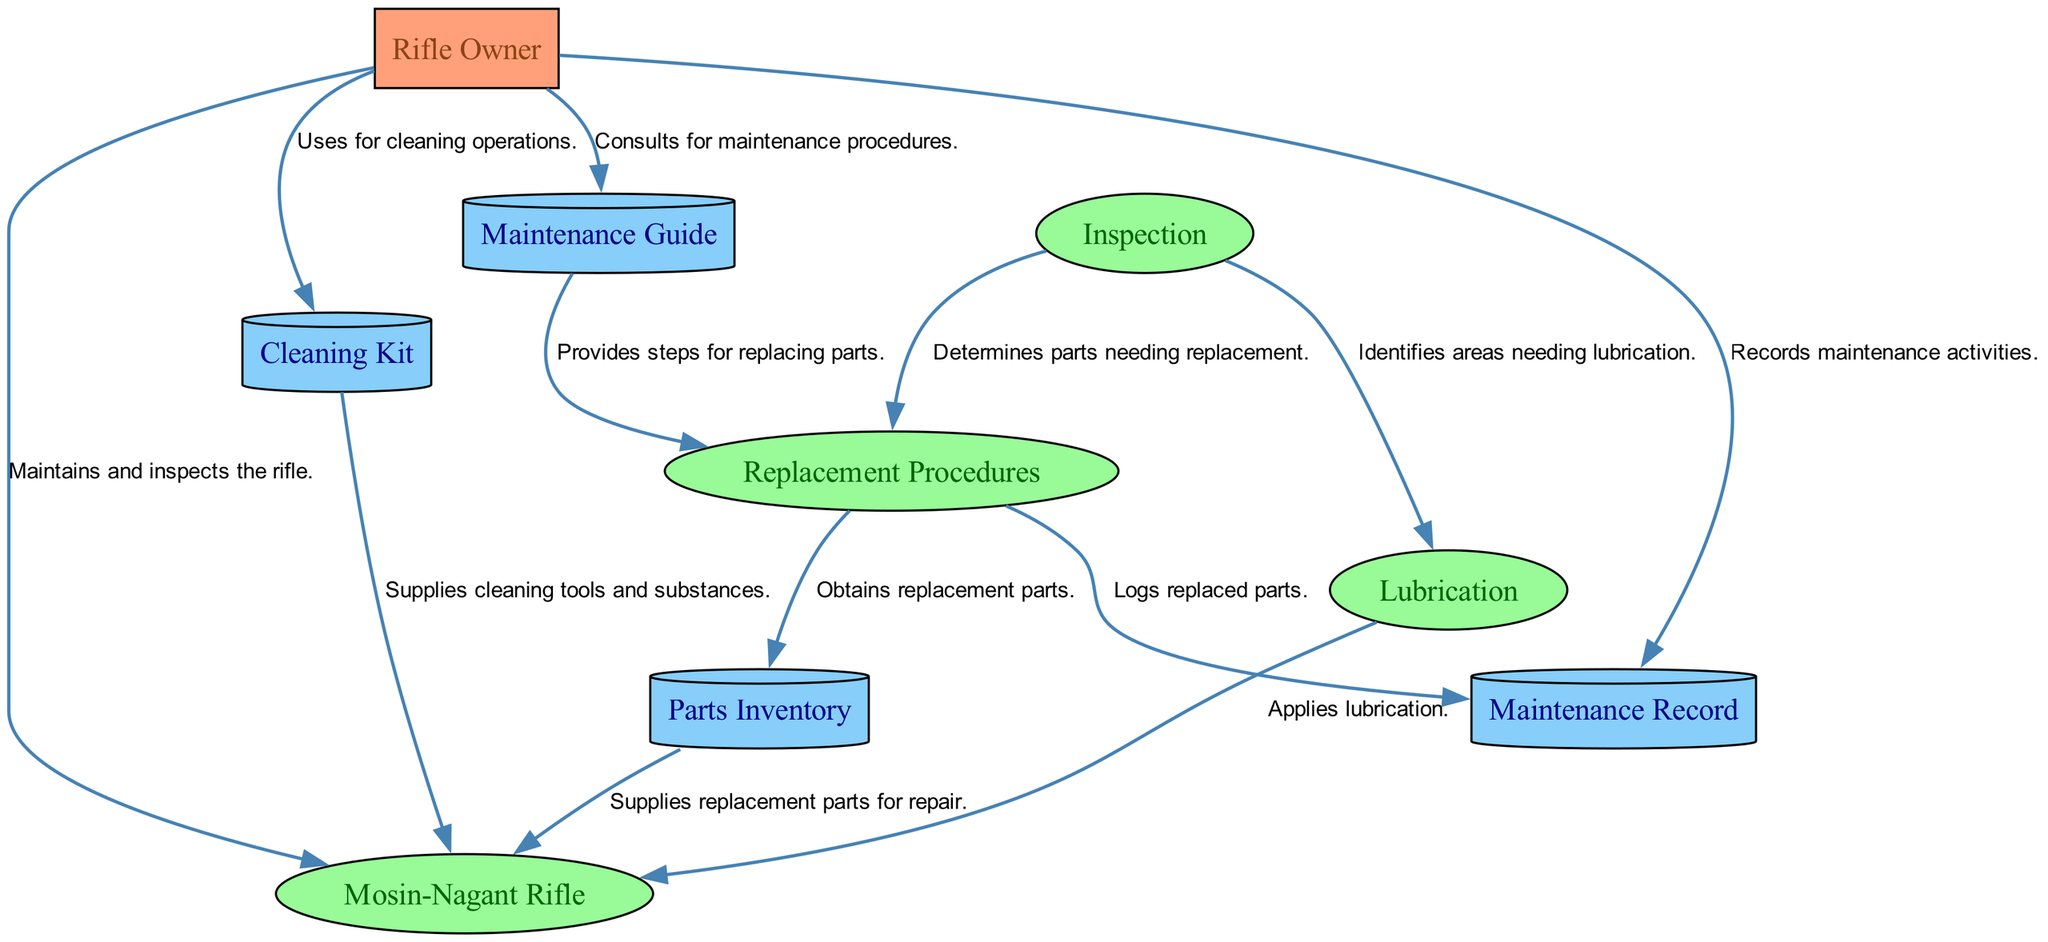What is the main process being maintained in this diagram? The diagram focuses on the Mosin-Nagant Rifle, which is identified as the main process in the entity list.
Answer: Mosin-Nagant Rifle How many external entities are present in the diagram? There is one external entity, which is the Rifle Owner responsible for maintenance and inspections.
Answer: One What is the purpose of the Maintenance Guide? It provides documentation detailing the steps for maintaining and replacing parts on the Mosin-Nagant rifle.
Answer: Documentation Which process identifies areas needing lubrication? The Inspection process is responsible for identifying areas that require lubrication based on its review of the rifle’s condition.
Answer: Inspection What does the Rifle Owner use for cleaning operations? The Rifle Owner uses a Cleaning Kit, which contains supplies and tools necessary for basic cleaning routines of the rifle.
Answer: Cleaning Kit How does the Replacement Procedures process obtain necessary parts? It obtains replacement parts from the Parts Inventory after determining which parts need to be replaced based on the inspection.
Answer: Parts Inventory Which data store logs all maintenance activities performed on the rifle? The Maintenance Record is the data store that records all activities related to the maintenance of the Mosin-Nagant rifle.
Answer: Maintenance Record What follows after the Inspection process? After inspection, the processes of Replacement Procedures and Lubrication follow, as they both depend on the findings from the inspection.
Answer: Replacement Procedures and Lubrication Which type of entity is the Parts Inventory classified as? The Parts Inventory is classified as a data store, indicated by its description as a stockpile of replacement parts.
Answer: Data store 